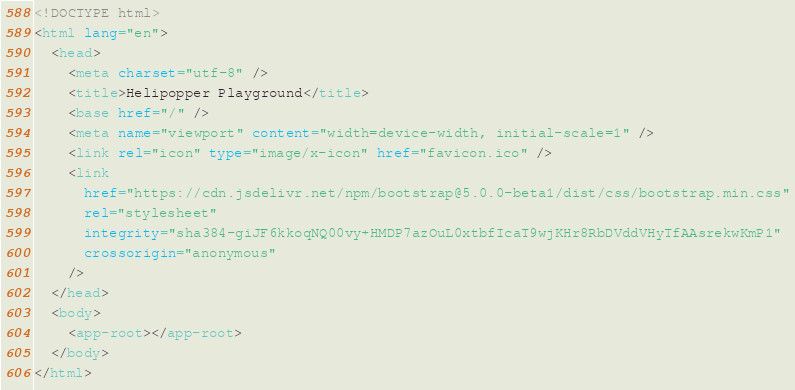<code> <loc_0><loc_0><loc_500><loc_500><_HTML_><!DOCTYPE html>
<html lang="en">
  <head>
    <meta charset="utf-8" />
    <title>Helipopper Playground</title>
    <base href="/" />
    <meta name="viewport" content="width=device-width, initial-scale=1" />
    <link rel="icon" type="image/x-icon" href="favicon.ico" />
    <link
      href="https://cdn.jsdelivr.net/npm/bootstrap@5.0.0-beta1/dist/css/bootstrap.min.css"
      rel="stylesheet"
      integrity="sha384-giJF6kkoqNQ00vy+HMDP7azOuL0xtbfIcaT9wjKHr8RbDVddVHyTfAAsrekwKmP1"
      crossorigin="anonymous"
    />
  </head>
  <body>
    <app-root></app-root>
  </body>
</html>
</code> 